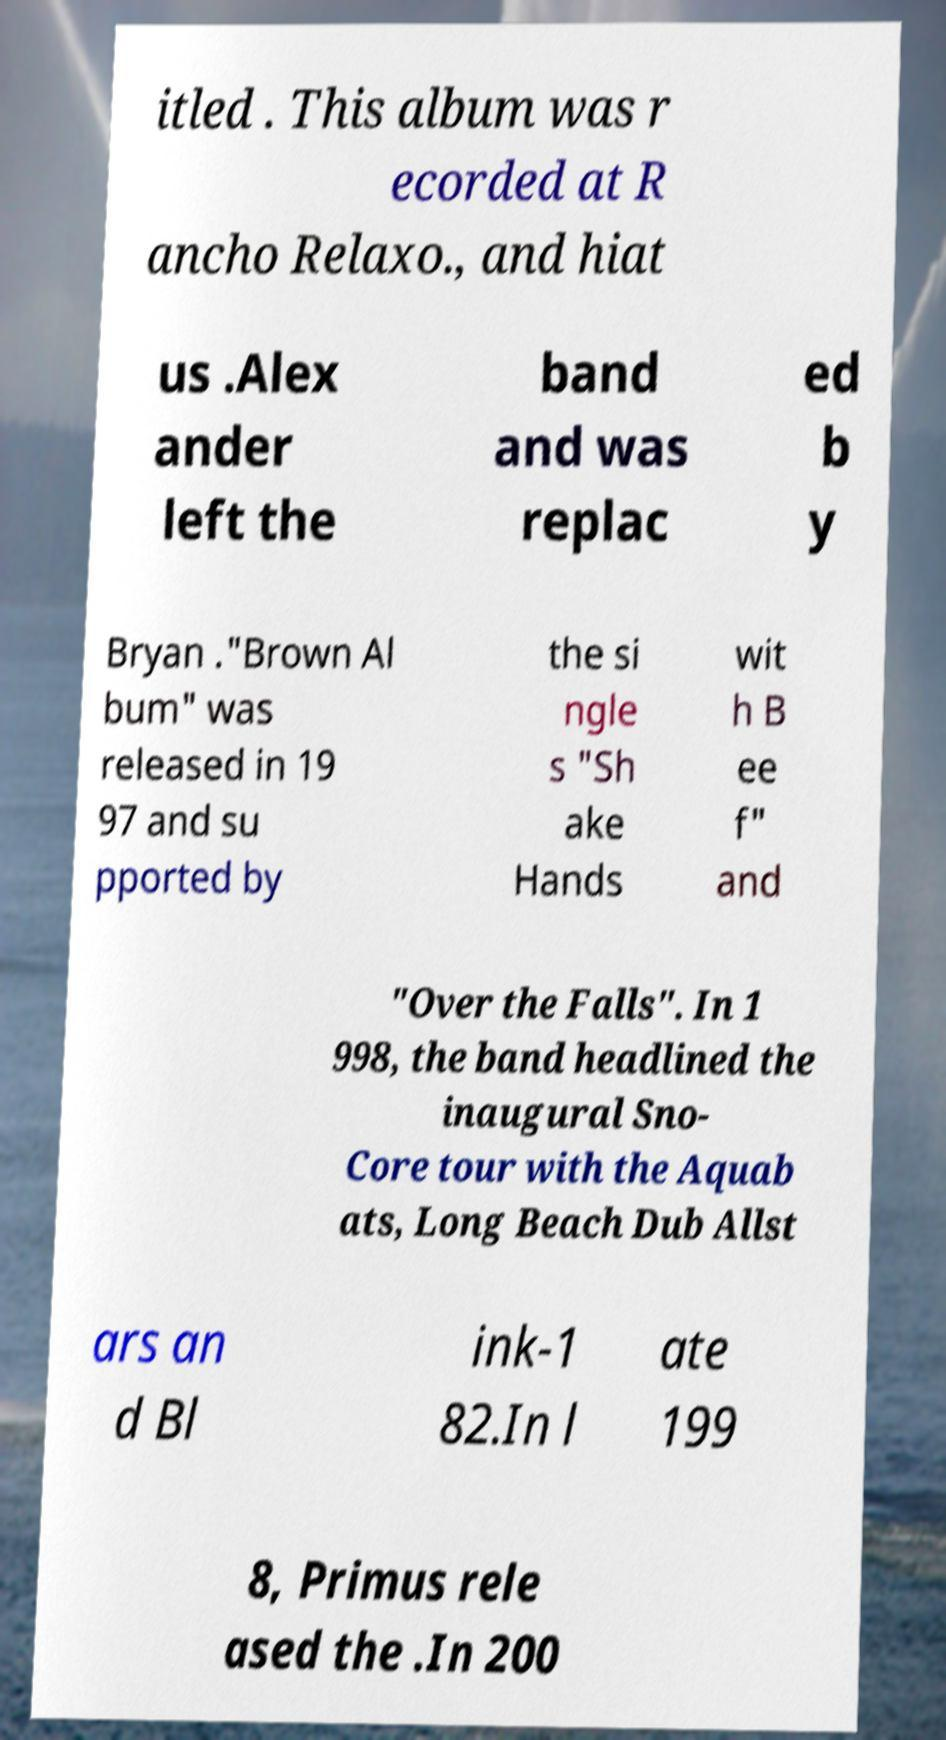Could you extract and type out the text from this image? itled . This album was r ecorded at R ancho Relaxo., and hiat us .Alex ander left the band and was replac ed b y Bryan ."Brown Al bum" was released in 19 97 and su pported by the si ngle s "Sh ake Hands wit h B ee f" and "Over the Falls". In 1 998, the band headlined the inaugural Sno- Core tour with the Aquab ats, Long Beach Dub Allst ars an d Bl ink-1 82.In l ate 199 8, Primus rele ased the .In 200 